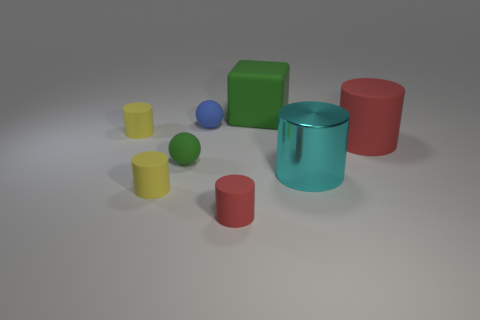Add 2 large cylinders. How many objects exist? 10 Subtract all cubes. How many objects are left? 7 Subtract all small gray things. Subtract all small yellow matte cylinders. How many objects are left? 6 Add 1 big rubber blocks. How many big rubber blocks are left? 2 Add 7 rubber cubes. How many rubber cubes exist? 8 Subtract 0 gray cylinders. How many objects are left? 8 